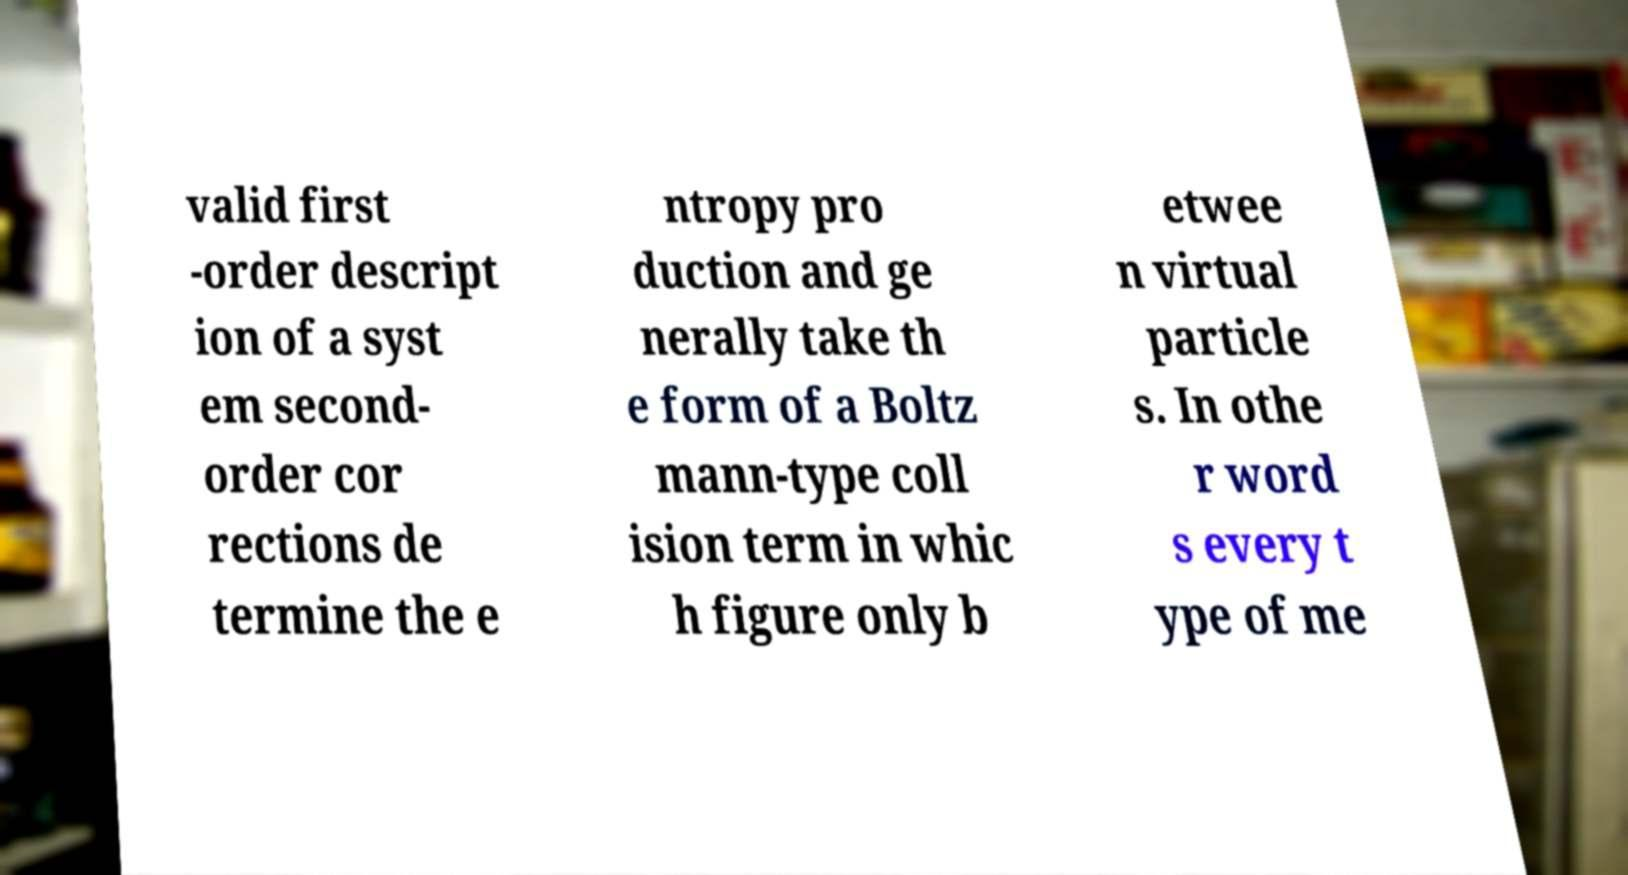I need the written content from this picture converted into text. Can you do that? valid first -order descript ion of a syst em second- order cor rections de termine the e ntropy pro duction and ge nerally take th e form of a Boltz mann-type coll ision term in whic h figure only b etwee n virtual particle s. In othe r word s every t ype of me 